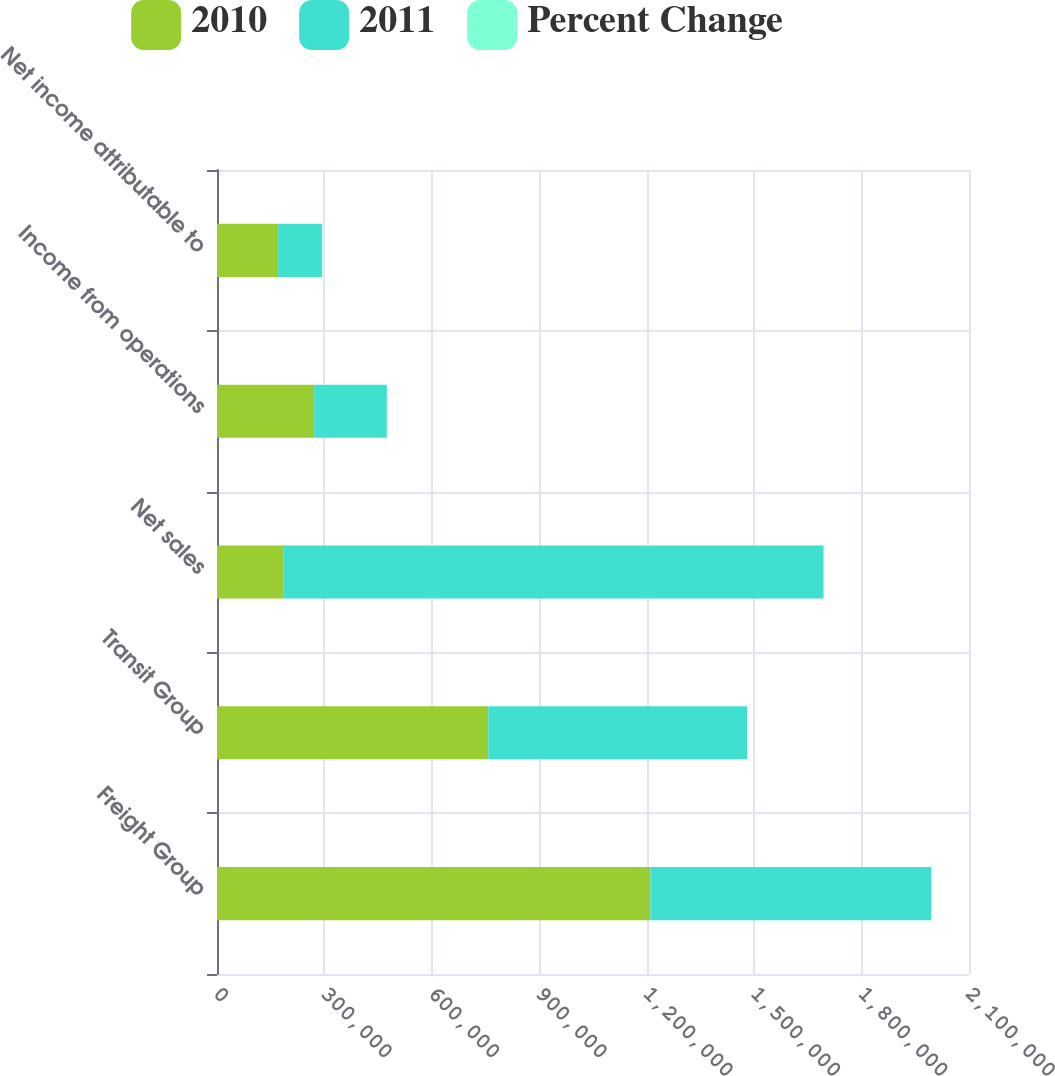<chart> <loc_0><loc_0><loc_500><loc_500><stacked_bar_chart><ecel><fcel>Freight Group<fcel>Transit Group<fcel>Net sales<fcel>Income from operations<fcel>Net income attributable to<nl><fcel>2010<fcel>1.21006e+06<fcel>757578<fcel>186700<fcel>271372<fcel>170591<nl><fcel>2011<fcel>784504<fcel>722508<fcel>1.50701e+06<fcel>202810<fcel>123099<nl><fcel>Percent Change<fcel>54.2<fcel>4.9<fcel>30.6<fcel>33.8<fcel>38.6<nl></chart> 